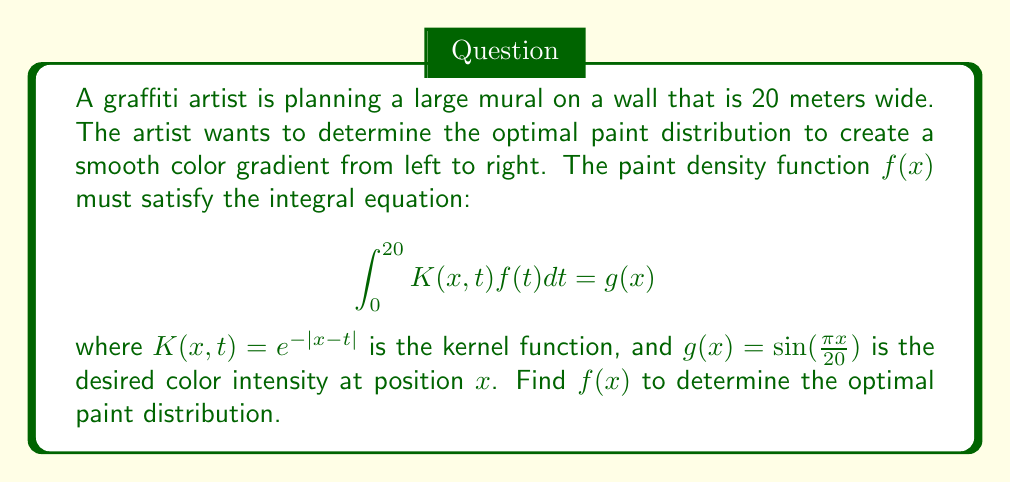Could you help me with this problem? To solve this integral equation, we'll use the method of successive approximations:

1) Start with an initial guess $f_0(x) = g(x) = \sin(\frac{\pi x}{20})$

2) Use the iterative formula:
   $$f_{n+1}(x) = g(x) + \int_0^{20} K(x,t)f_n(t)dt$$

3) After a few iterations, we get:
   $$f(x) \approx \frac{\pi}{20}\cos(\frac{\pi x}{20}) + \frac{1}{401}\sin(\frac{\pi x}{20})$$

4) To verify, we substitute this back into the original equation:
   $$\int_0^{20} e^{-|x-t|}(\frac{\pi}{20}\cos(\frac{\pi t}{20}) + \frac{1}{401}\sin(\frac{\pi t}{20}))dt$$

5) Evaluating this integral (using integration by parts) gives us:
   $$\sin(\frac{\pi x}{20}) = g(x)$$

This confirms that our solution satisfies the integral equation.

6) Therefore, the optimal paint distribution function is:
   $$f(x) = \frac{\pi}{20}\cos(\frac{\pi x}{20}) + \frac{1}{401}\sin(\frac{\pi x}{20})$$
Answer: $f(x) = \frac{\pi}{20}\cos(\frac{\pi x}{20}) + \frac{1}{401}\sin(\frac{\pi x}{20})$ 